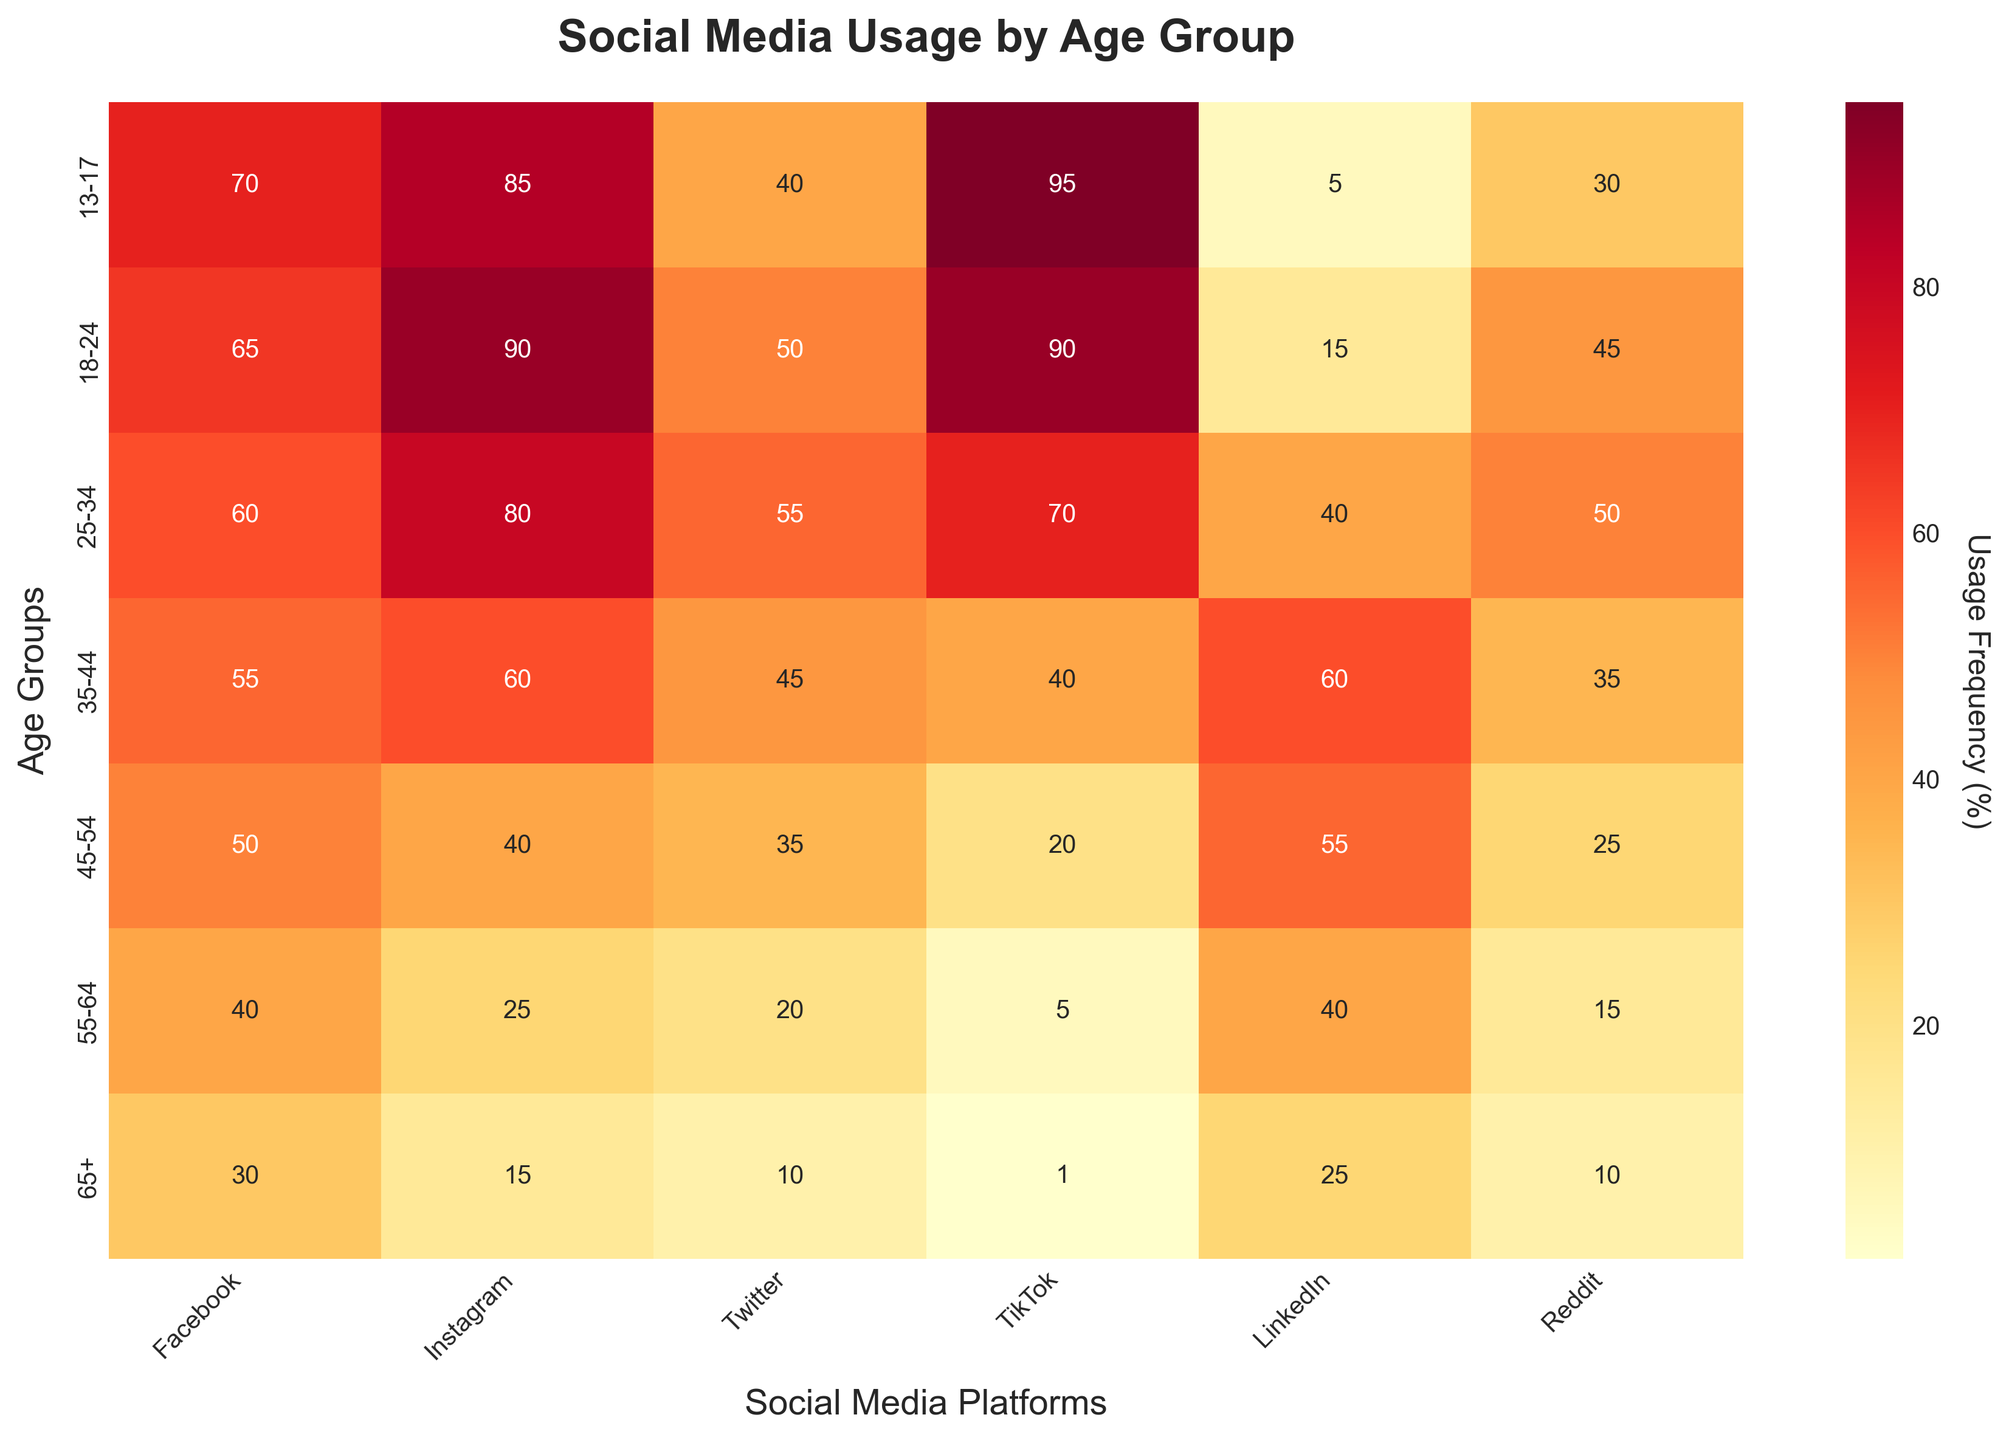What is the percentage of TikTok usage among the 13-17 age group? To find the percentage of TikTok usage among the 13-17 age group, look at the corresponding cell in the heatmap where the '13-17' age group and 'TikTok' column intersect.
Answer: 95% Which age group uses LinkedIn the most? Identify the age group with the highest value in the 'LinkedIn' column. The highest value indicates the most significant usage.
Answer: 35-44 What is the title of the heatmap? The title is displayed at the top of the heatmap plot, summarizing the chart's content.
Answer: Social Media Usage by Age Group Which platform has the least usage among the 45-54 age group? Look at the '45-54' row and identify the platform with the smallest percentage value.
Answer: TikTok Compare the Instagram usage between the 18-24 and 25-34 age groups. Which one is higher? Locate the 'Instagram' column and compare the values for the '18-24' and '25-34' age groups. The higher value indicates greater usage.
Answer: 18-24 What is the average frequency of Facebook usage across all age groups? Sum the Facebook usage percentages across all age groups: (70 + 65 + 60 + 55 + 50 + 40 + 30) = 370. Then divide by the number of age groups, which is 7.
Answer: 52.86 Which social media platform is most frequently used by the 25-34 age group? Find the row corresponding to the '25-34' age group, and then identify the column with the highest value in that row.
Answer: Reddit How does Twitter usage in the 55-64 age group compare to that in the 65+ age group? Compare the values in the 'Twitter' column for the '55-64' and '65+' age groups. The difference in values shows the comparison.
Answer: Higher in 55-64 What is the color used to represent the highest frequency of social media usage? Look at the color palette in the heatmap and identify the color shaded in the cell with the highest value.
Answer: Darkest Red Which age group shows the most diverse social media usage, indicated by the largest range of usage percentages across all platforms? Calculate the range (difference between the highest and lowest values) for each age group. The age group with the largest range has the most diverse usage.
Answer: 13-17 (95-5=90) 